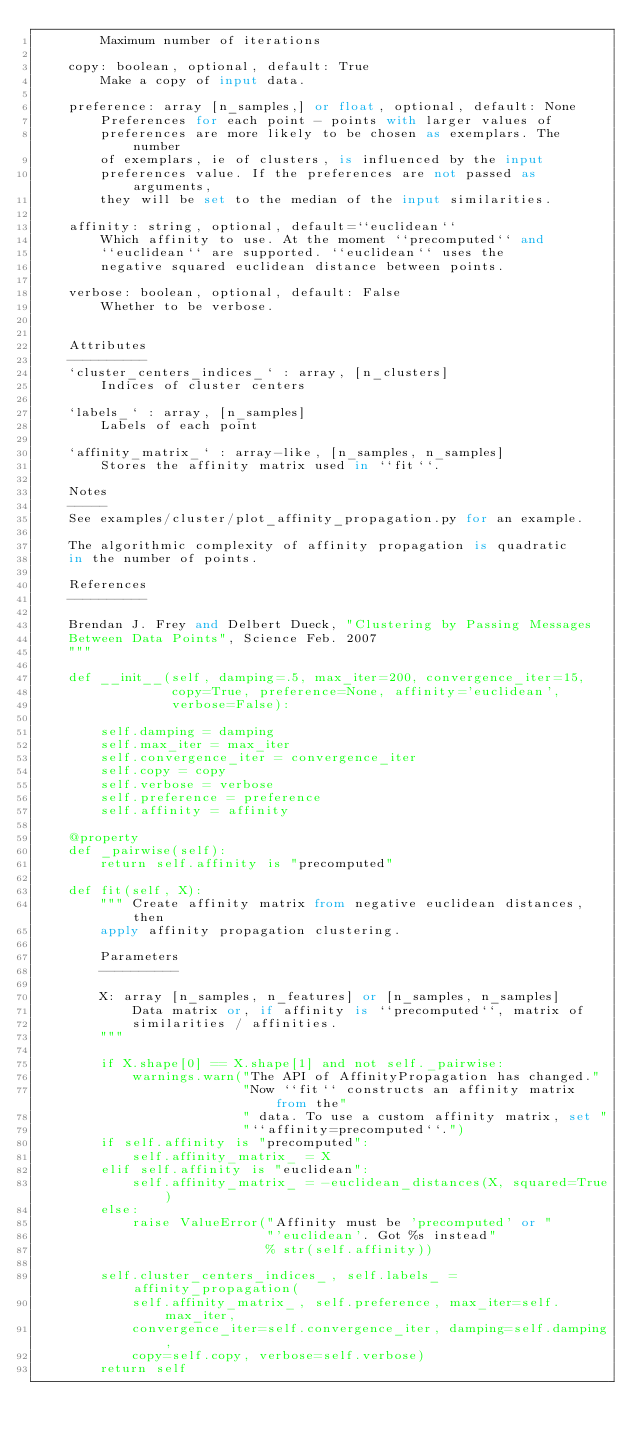<code> <loc_0><loc_0><loc_500><loc_500><_Python_>        Maximum number of iterations

    copy: boolean, optional, default: True
        Make a copy of input data.

    preference: array [n_samples,] or float, optional, default: None
        Preferences for each point - points with larger values of
        preferences are more likely to be chosen as exemplars. The number
        of exemplars, ie of clusters, is influenced by the input
        preferences value. If the preferences are not passed as arguments,
        they will be set to the median of the input similarities.

    affinity: string, optional, default=``euclidean``
        Which affinity to use. At the moment ``precomputed`` and
        ``euclidean`` are supported. ``euclidean`` uses the
        negative squared euclidean distance between points.

    verbose: boolean, optional, default: False
        Whether to be verbose.


    Attributes
    ----------
    `cluster_centers_indices_` : array, [n_clusters]
        Indices of cluster centers

    `labels_` : array, [n_samples]
        Labels of each point

    `affinity_matrix_` : array-like, [n_samples, n_samples]
        Stores the affinity matrix used in ``fit``.

    Notes
    -----
    See examples/cluster/plot_affinity_propagation.py for an example.

    The algorithmic complexity of affinity propagation is quadratic
    in the number of points.

    References
    ----------

    Brendan J. Frey and Delbert Dueck, "Clustering by Passing Messages
    Between Data Points", Science Feb. 2007
    """

    def __init__(self, damping=.5, max_iter=200, convergence_iter=15,
                 copy=True, preference=None, affinity='euclidean',
                 verbose=False):

        self.damping = damping
        self.max_iter = max_iter
        self.convergence_iter = convergence_iter
        self.copy = copy
        self.verbose = verbose
        self.preference = preference
        self.affinity = affinity

    @property
    def _pairwise(self):
        return self.affinity is "precomputed"

    def fit(self, X):
        """ Create affinity matrix from negative euclidean distances, then
        apply affinity propagation clustering.

        Parameters
        ----------

        X: array [n_samples, n_features] or [n_samples, n_samples]
            Data matrix or, if affinity is ``precomputed``, matrix of
            similarities / affinities.
        """

        if X.shape[0] == X.shape[1] and not self._pairwise:
            warnings.warn("The API of AffinityPropagation has changed."
                          "Now ``fit`` constructs an affinity matrix from the"
                          " data. To use a custom affinity matrix, set "
                          "``affinity=precomputed``.")
        if self.affinity is "precomputed":
            self.affinity_matrix_ = X
        elif self.affinity is "euclidean":
            self.affinity_matrix_ = -euclidean_distances(X, squared=True)
        else:
            raise ValueError("Affinity must be 'precomputed' or "
                             "'euclidean'. Got %s instead"
                             % str(self.affinity))

        self.cluster_centers_indices_, self.labels_ = affinity_propagation(
            self.affinity_matrix_, self.preference, max_iter=self.max_iter,
            convergence_iter=self.convergence_iter, damping=self.damping,
            copy=self.copy, verbose=self.verbose)
        return self
</code> 